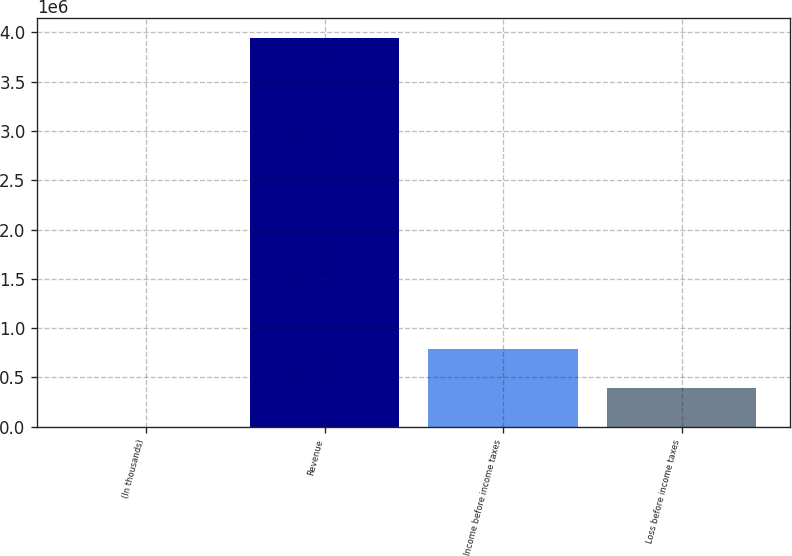<chart> <loc_0><loc_0><loc_500><loc_500><bar_chart><fcel>(In thousands)<fcel>Revenue<fcel>Income before income taxes<fcel>Loss before income taxes<nl><fcel>2012<fcel>3.94494e+06<fcel>790598<fcel>396305<nl></chart> 